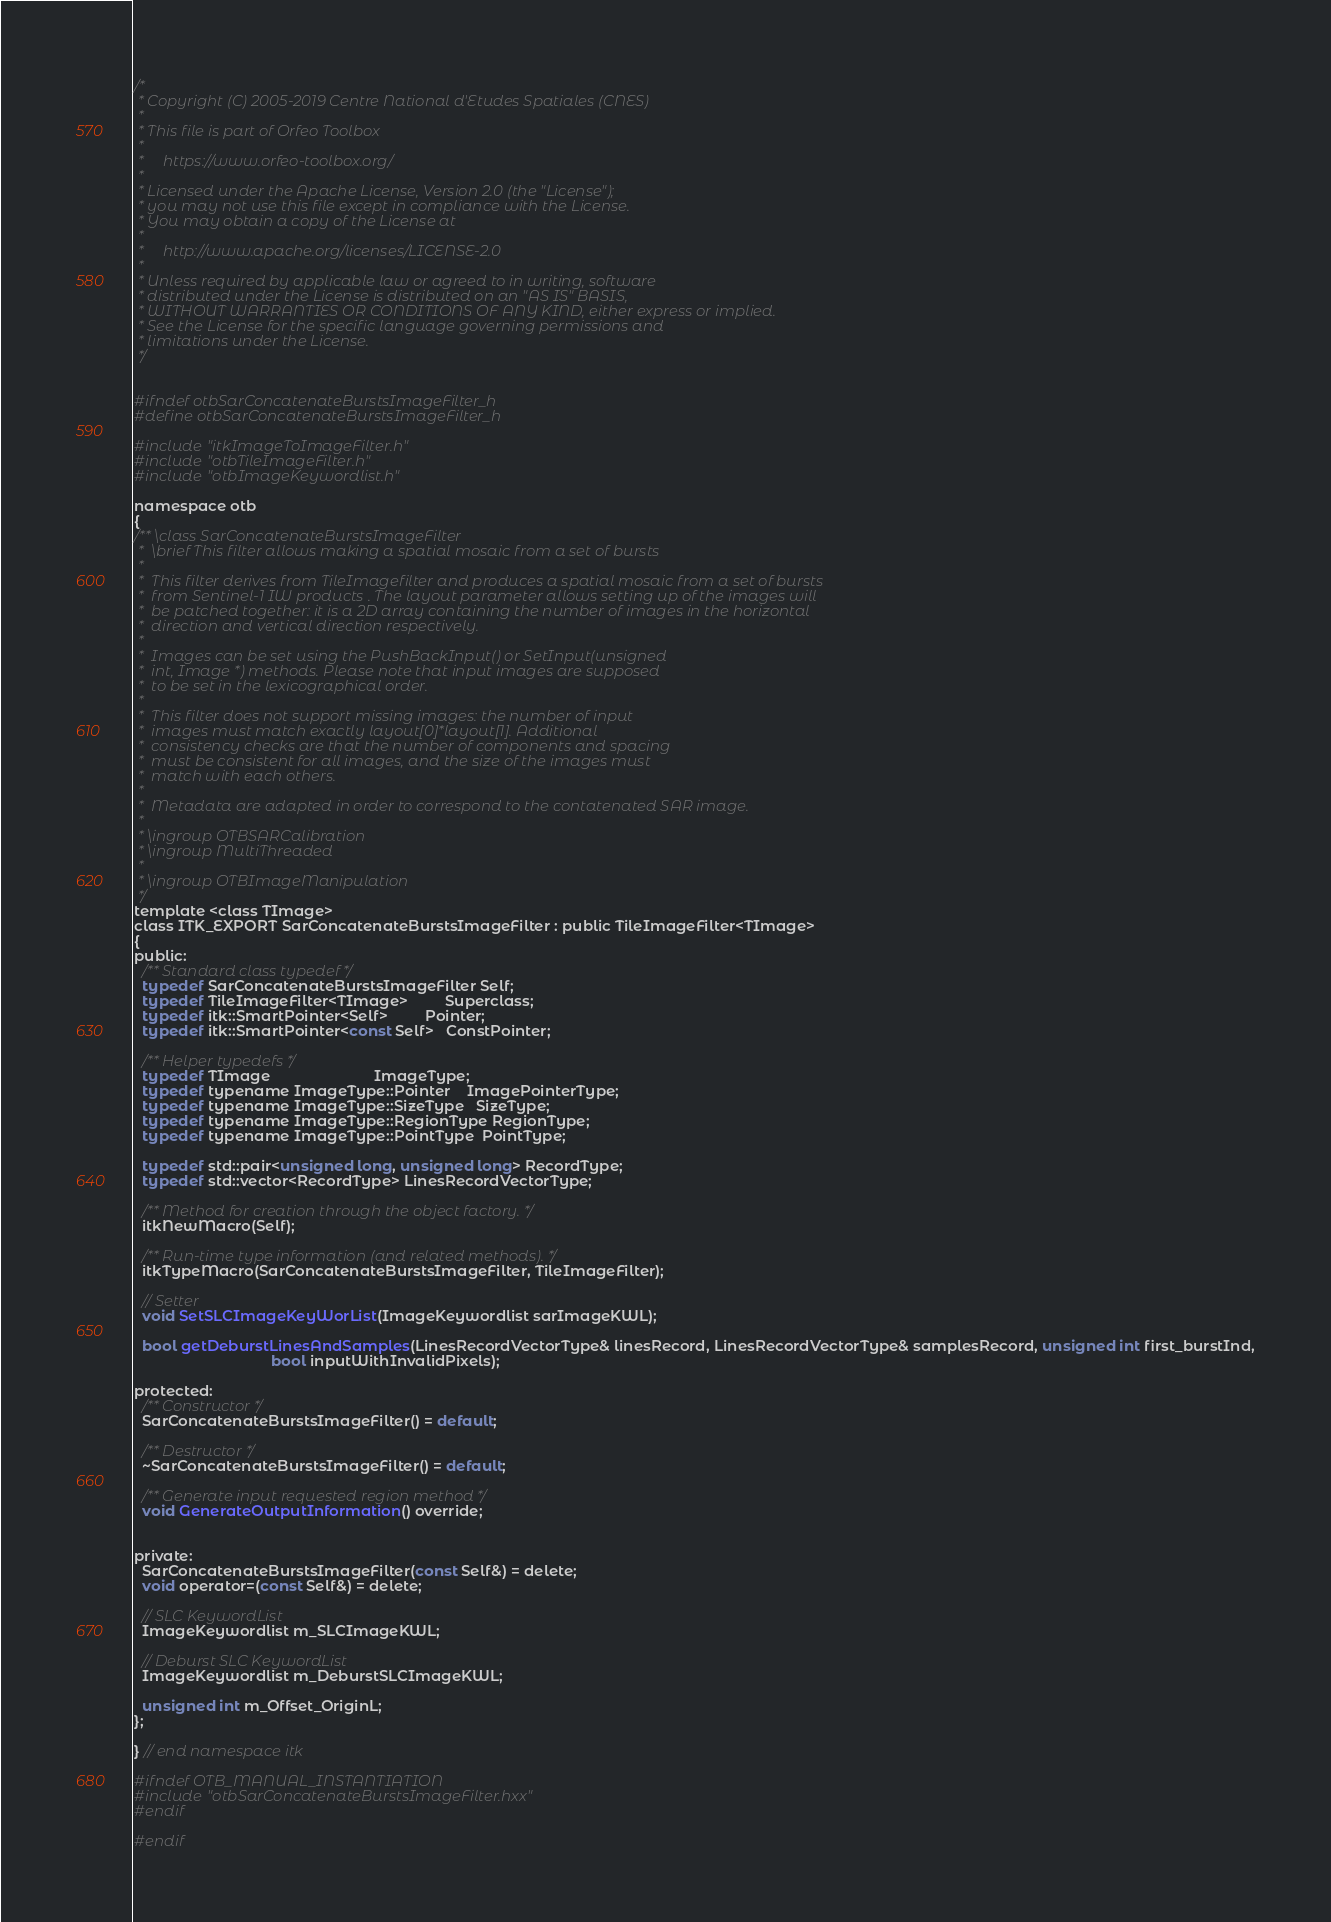Convert code to text. <code><loc_0><loc_0><loc_500><loc_500><_C_>/*
 * Copyright (C) 2005-2019 Centre National d'Etudes Spatiales (CNES)
 *
 * This file is part of Orfeo Toolbox
 *
 *     https://www.orfeo-toolbox.org/
 *
 * Licensed under the Apache License, Version 2.0 (the "License");
 * you may not use this file except in compliance with the License.
 * You may obtain a copy of the License at
 *
 *     http://www.apache.org/licenses/LICENSE-2.0
 *
 * Unless required by applicable law or agreed to in writing, software
 * distributed under the License is distributed on an "AS IS" BASIS,
 * WITHOUT WARRANTIES OR CONDITIONS OF ANY KIND, either express or implied.
 * See the License for the specific language governing permissions and
 * limitations under the License.
 */


#ifndef otbSarConcatenateBurstsImageFilter_h
#define otbSarConcatenateBurstsImageFilter_h

#include "itkImageToImageFilter.h"
#include "otbTileImageFilter.h"
#include "otbImageKeywordlist.h"

namespace otb
{
/** \class SarConcatenateBurstsImageFilter
 *  \brief This filter allows making a spatial mosaic from a set of bursts
 *
 *  This filter derives from TileImagefilter and produces a spatial mosaic from a set of bursts
 *  from Sentinel-1 IW products . The layout parameter allows setting up of the images will
 *  be patched together: it is a 2D array containing the number of images in the horizontal
 *  direction and vertical direction respectively.
 *
 *  Images can be set using the PushBackInput() or SetInput(unsigned
 *  int, Image *) methods. Please note that input images are supposed
 *  to be set in the lexicographical order.
 *
 *  This filter does not support missing images: the number of input
 *  images must match exactly layout[0]*layout[1]. Additional
 *  consistency checks are that the number of components and spacing
 *  must be consistent for all images, and the size of the images must
 *  match with each others.
 *
 *  Metadata are adapted in order to correspond to the contatenated SAR image.
 *
 * \ingroup OTBSARCalibration
 * \ingroup MultiThreaded
 *
 * \ingroup OTBImageManipulation
 */
template <class TImage>
class ITK_EXPORT SarConcatenateBurstsImageFilter : public TileImageFilter<TImage>
{
public:
  /** Standard class typedef */
  typedef SarConcatenateBurstsImageFilter Self;
  typedef TileImageFilter<TImage>         Superclass;
  typedef itk::SmartPointer<Self>         Pointer;
  typedef itk::SmartPointer<const Self>   ConstPointer;

  /** Helper typedefs */
  typedef TImage                         ImageType;
  typedef typename ImageType::Pointer    ImagePointerType;
  typedef typename ImageType::SizeType   SizeType;
  typedef typename ImageType::RegionType RegionType;
  typedef typename ImageType::PointType  PointType;

  typedef std::pair<unsigned long, unsigned long> RecordType;
  typedef std::vector<RecordType> LinesRecordVectorType;

  /** Method for creation through the object factory. */
  itkNewMacro(Self);

  /** Run-time type information (and related methods). */
  itkTypeMacro(SarConcatenateBurstsImageFilter, TileImageFilter);

  // Setter
  void SetSLCImageKeyWorList(ImageKeywordlist sarImageKWL);

  bool getDeburstLinesAndSamples(LinesRecordVectorType& linesRecord, LinesRecordVectorType& samplesRecord, unsigned int first_burstInd,
                                 bool inputWithInvalidPixels);

protected:
  /** Constructor */
  SarConcatenateBurstsImageFilter() = default;

  /** Destructor */
  ~SarConcatenateBurstsImageFilter() = default;

  /** Generate input requested region method */
  void GenerateOutputInformation() override;


private:
  SarConcatenateBurstsImageFilter(const Self&) = delete;
  void operator=(const Self&) = delete;

  // SLC KeywordList
  ImageKeywordlist m_SLCImageKWL;

  // Deburst SLC KeywordList
  ImageKeywordlist m_DeburstSLCImageKWL;

  unsigned int m_Offset_OriginL;
};

} // end namespace itk

#ifndef OTB_MANUAL_INSTANTIATION
#include "otbSarConcatenateBurstsImageFilter.hxx"
#endif

#endif
</code> 